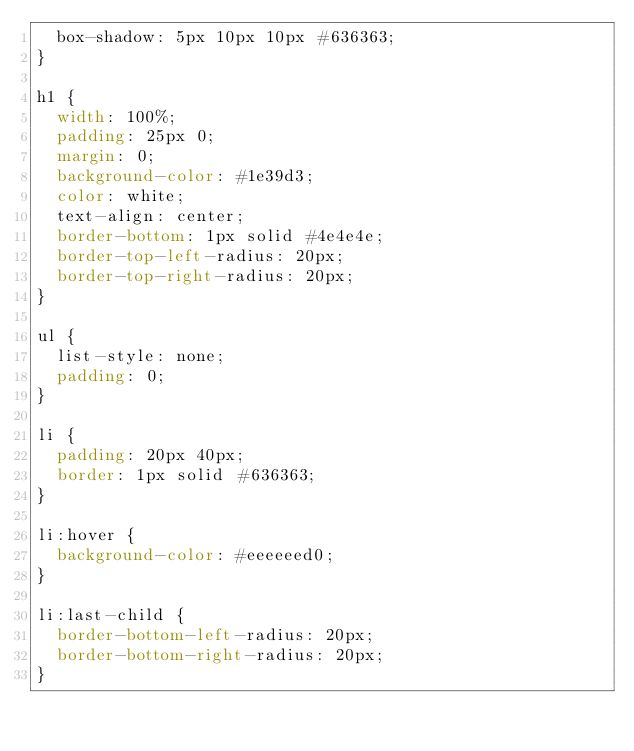Convert code to text. <code><loc_0><loc_0><loc_500><loc_500><_CSS_>  box-shadow: 5px 10px 10px #636363;
}

h1 {
  width: 100%;
  padding: 25px 0;
  margin: 0;
  background-color: #1e39d3;
  color: white;
  text-align: center;
  border-bottom: 1px solid #4e4e4e;
  border-top-left-radius: 20px;
  border-top-right-radius: 20px;
}

ul {
  list-style: none;
  padding: 0;
}

li {
  padding: 20px 40px;
  border: 1px solid #636363;
}

li:hover {
  background-color: #eeeeeed0;
}

li:last-child {
  border-bottom-left-radius: 20px;
  border-bottom-right-radius: 20px;
}
</code> 